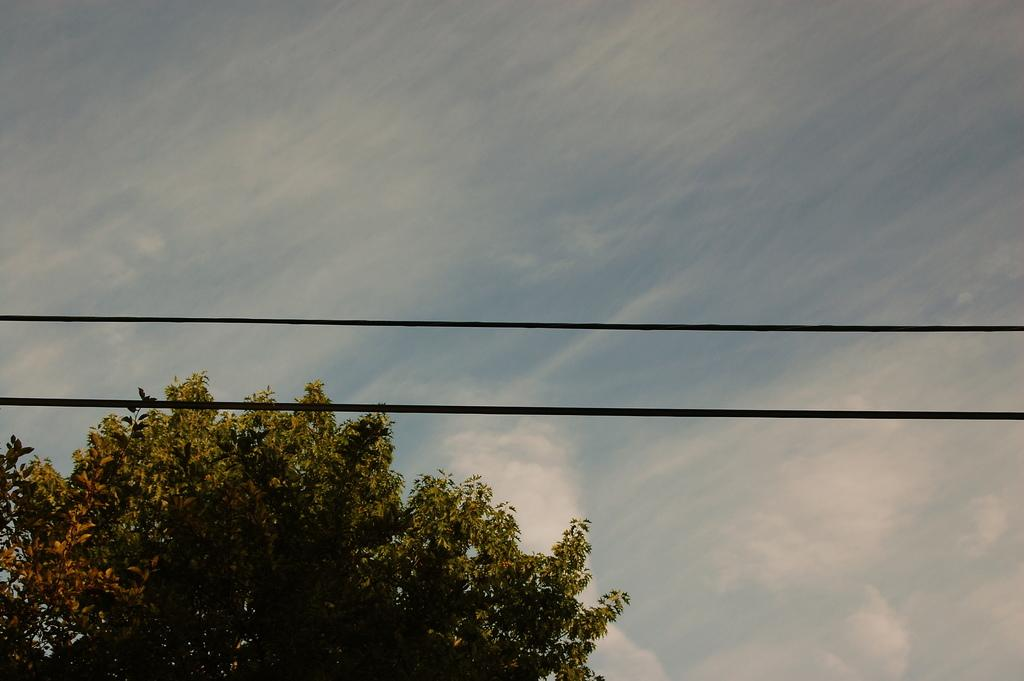How many wires can be seen in the image? There are two wires in the image. What can be seen in the background of the image? The sky with clouds is visible in the background of the image. What is located at the bottom of the image? There is a tree at the bottom of the image. What type of truck is parked next to the tree in the image? There is no truck present in the image; it only features two wires, a sky with clouds, and a tree. 